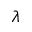<formula> <loc_0><loc_0><loc_500><loc_500>\lambda</formula> 